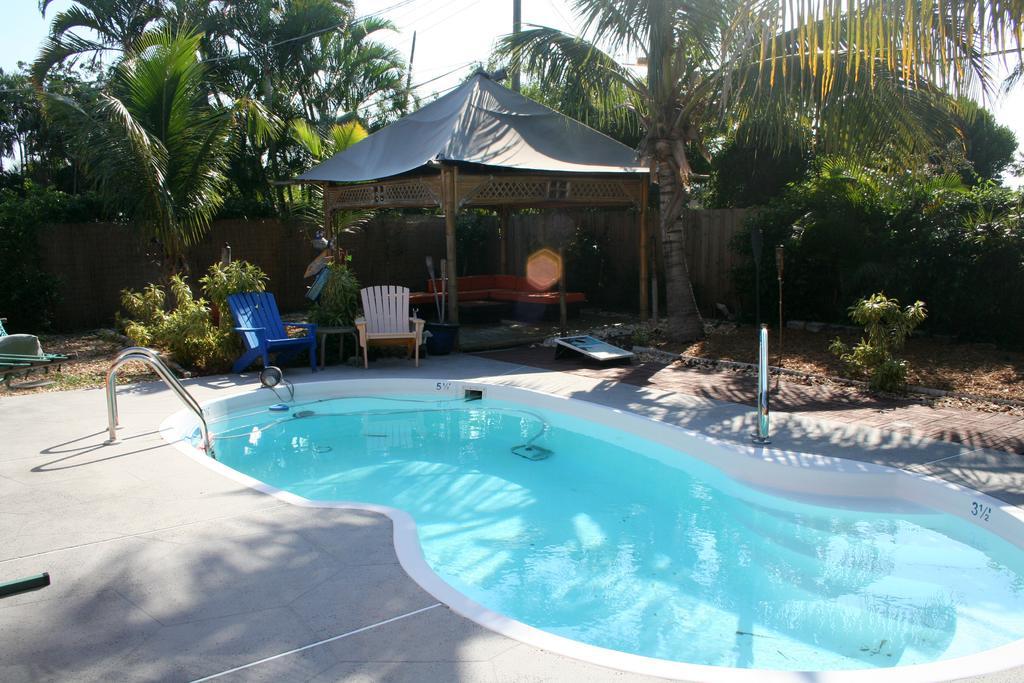Please provide a concise description of this image. This picture is clicked outside. In the foreground we can see the ground, swimming pool, metal rods, chairs, tent and plants, trees and some other objects. In the background we can see the sky, trees and some other objects. 